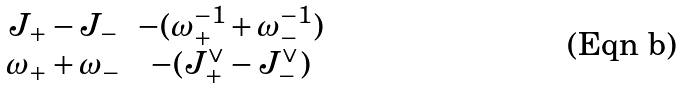Convert formula to latex. <formula><loc_0><loc_0><loc_500><loc_500>\begin{matrix} J _ { + } - J _ { - } & - ( \omega _ { + } ^ { - 1 } + \omega _ { - } ^ { - 1 } ) \\ \omega _ { + } + \omega _ { - } & - ( J ^ { \vee } _ { + } - J ^ { \vee } _ { - } ) \end{matrix}</formula> 